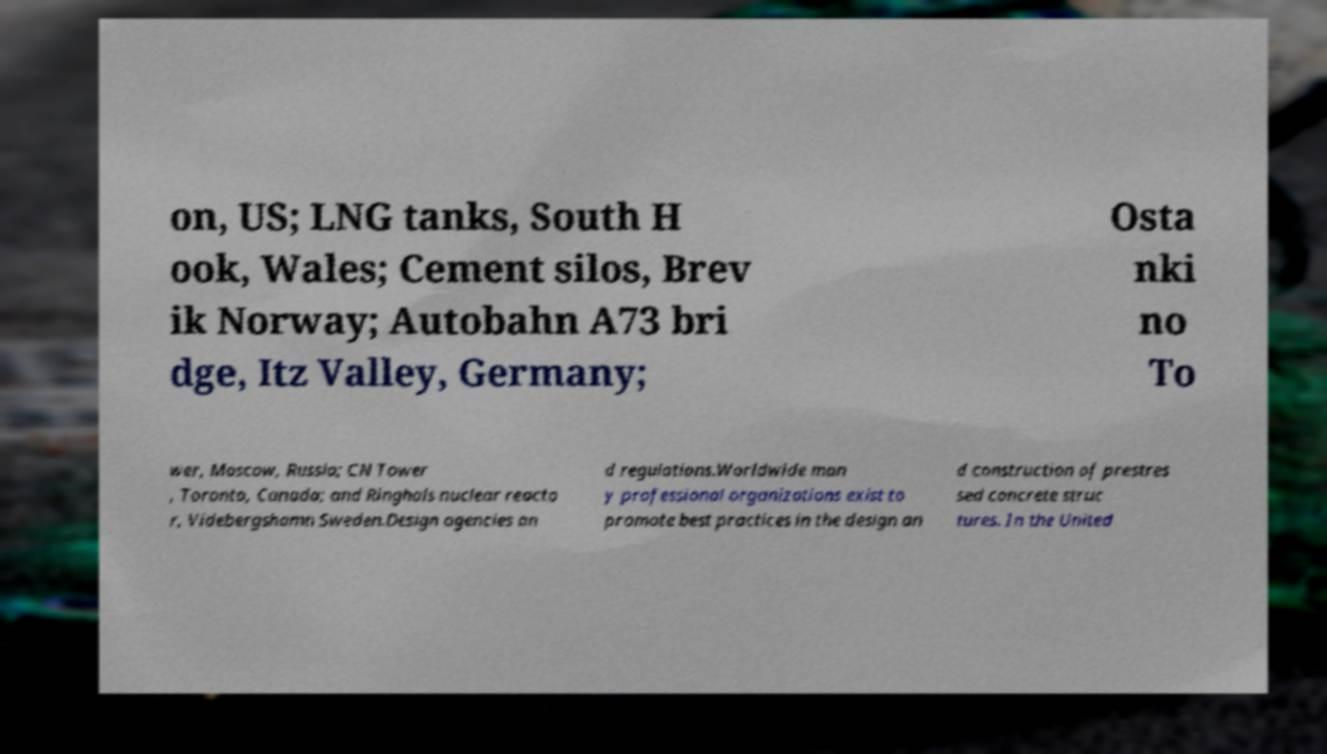There's text embedded in this image that I need extracted. Can you transcribe it verbatim? on, US; LNG tanks, South H ook, Wales; Cement silos, Brev ik Norway; Autobahn A73 bri dge, Itz Valley, Germany; Osta nki no To wer, Moscow, Russia; CN Tower , Toronto, Canada; and Ringhals nuclear reacto r, Videbergshamn Sweden.Design agencies an d regulations.Worldwide man y professional organizations exist to promote best practices in the design an d construction of prestres sed concrete struc tures. In the United 